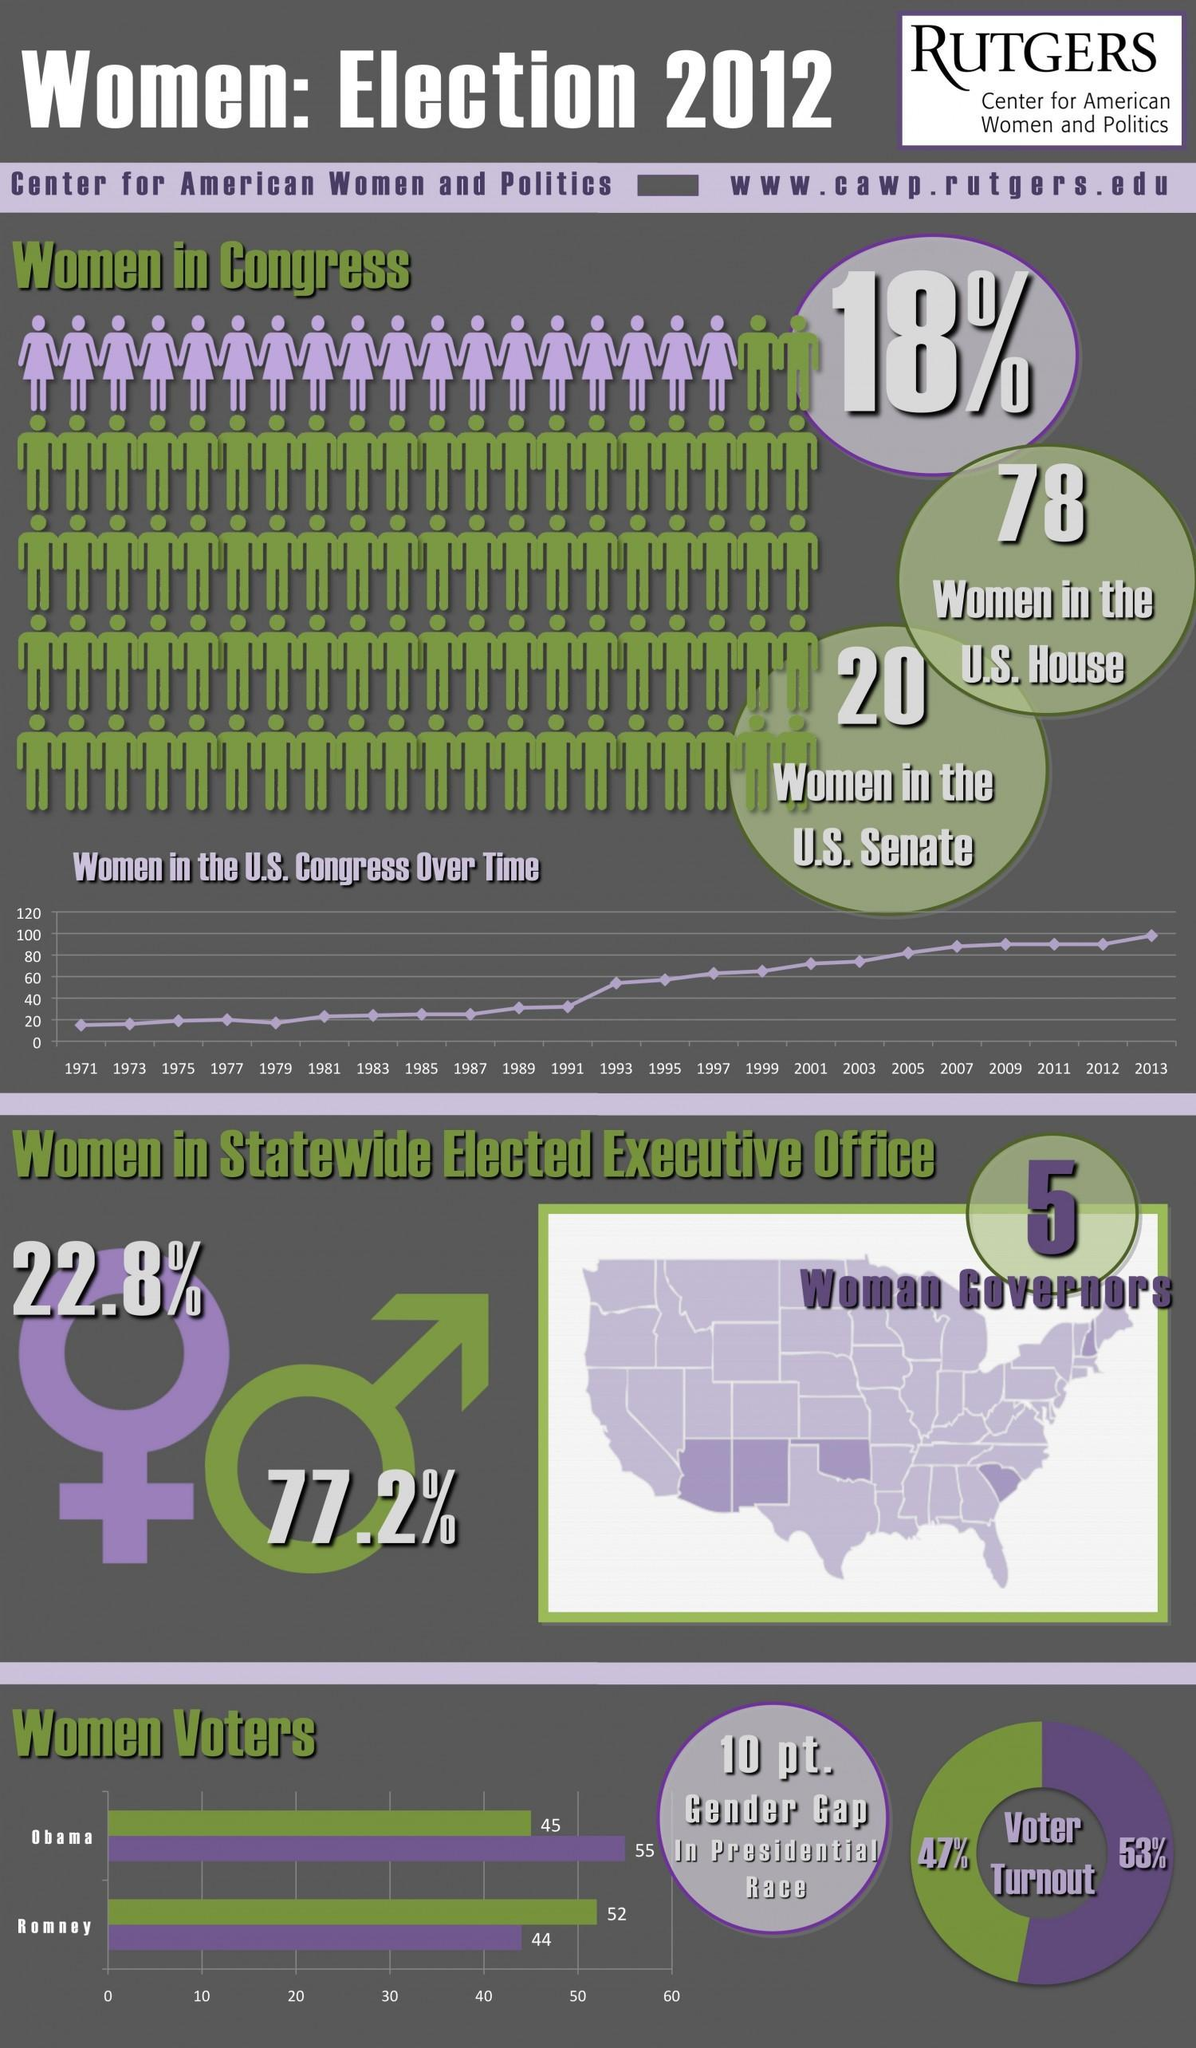What percentage of men voted for Romney in the 2012 U.S. Presidential election?
Answer the question with a short phrase. 52 What percentage of women were eligible to cast vote in the 2012 U.S. Presidential election? 53% What percentage of women voted for Obama in the 2012 U.S. Presidential election? 55 What is the percentage of women in the statewide elected executive office in the U.S. in 2012? 22.8% What percentage of men represented in the U.S. Congress in 2012? 82% What percentage of men were eligible to cast vote in the 2012 U.S. Presidential election? 47% What is the percentage of men in the statewide elected executive office in the U.S. in 2012? 77.2% 